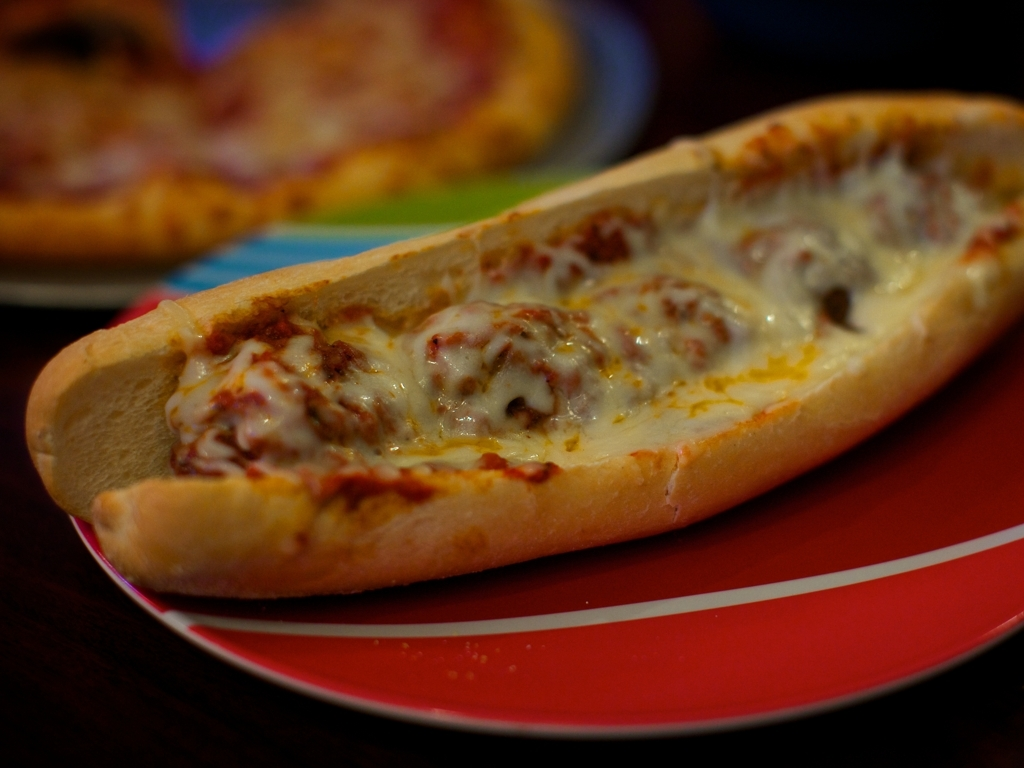What type of food is shown in the image? The image displays a cheese-covered sub sandwich, likely containing some form of meat like meatballs, on a toasted bun. 